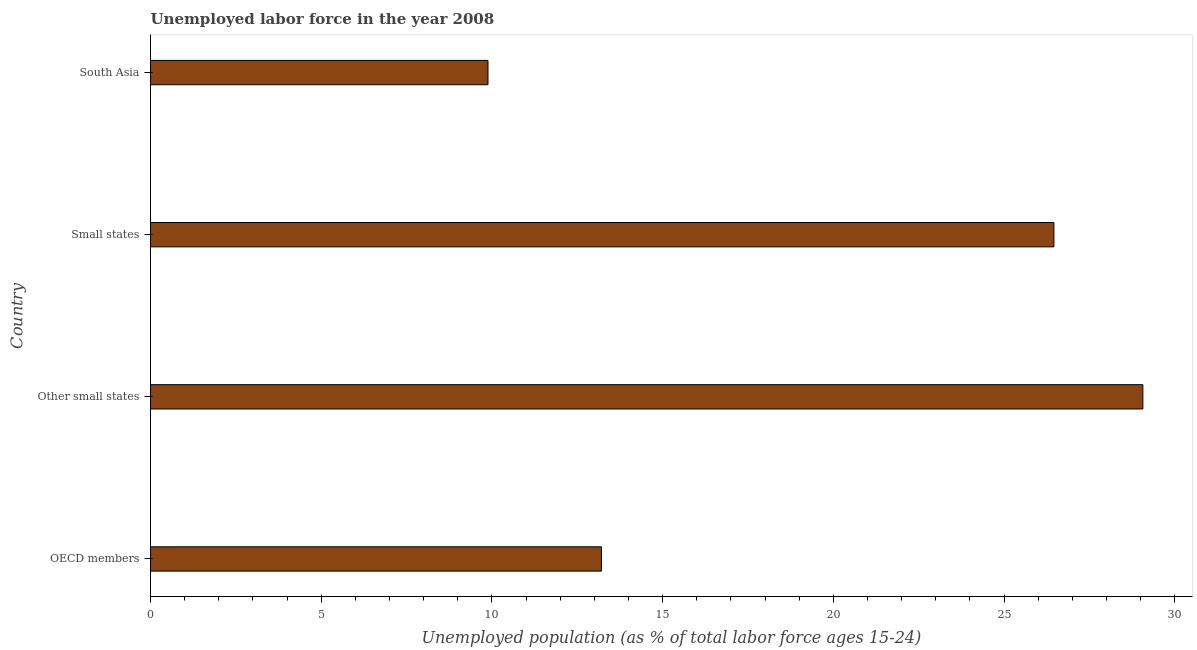What is the title of the graph?
Your answer should be very brief. Unemployed labor force in the year 2008. What is the label or title of the X-axis?
Your response must be concise. Unemployed population (as % of total labor force ages 15-24). What is the label or title of the Y-axis?
Provide a succinct answer. Country. What is the total unemployed youth population in South Asia?
Your answer should be very brief. 9.88. Across all countries, what is the maximum total unemployed youth population?
Make the answer very short. 29.07. Across all countries, what is the minimum total unemployed youth population?
Your answer should be compact. 9.88. In which country was the total unemployed youth population maximum?
Keep it short and to the point. Other small states. What is the sum of the total unemployed youth population?
Give a very brief answer. 78.62. What is the difference between the total unemployed youth population in Other small states and South Asia?
Your answer should be compact. 19.18. What is the average total unemployed youth population per country?
Ensure brevity in your answer.  19.65. What is the median total unemployed youth population?
Keep it short and to the point. 19.83. What is the ratio of the total unemployed youth population in OECD members to that in South Asia?
Offer a terse response. 1.34. What is the difference between the highest and the second highest total unemployed youth population?
Provide a succinct answer. 2.61. Is the sum of the total unemployed youth population in Other small states and Small states greater than the maximum total unemployed youth population across all countries?
Give a very brief answer. Yes. What is the difference between the highest and the lowest total unemployed youth population?
Your answer should be compact. 19.18. In how many countries, is the total unemployed youth population greater than the average total unemployed youth population taken over all countries?
Provide a short and direct response. 2. Are all the bars in the graph horizontal?
Offer a very short reply. Yes. Are the values on the major ticks of X-axis written in scientific E-notation?
Ensure brevity in your answer.  No. What is the Unemployed population (as % of total labor force ages 15-24) of OECD members?
Make the answer very short. 13.21. What is the Unemployed population (as % of total labor force ages 15-24) of Other small states?
Ensure brevity in your answer.  29.07. What is the Unemployed population (as % of total labor force ages 15-24) of Small states?
Provide a succinct answer. 26.46. What is the Unemployed population (as % of total labor force ages 15-24) of South Asia?
Ensure brevity in your answer.  9.88. What is the difference between the Unemployed population (as % of total labor force ages 15-24) in OECD members and Other small states?
Make the answer very short. -15.86. What is the difference between the Unemployed population (as % of total labor force ages 15-24) in OECD members and Small states?
Provide a short and direct response. -13.25. What is the difference between the Unemployed population (as % of total labor force ages 15-24) in OECD members and South Asia?
Keep it short and to the point. 3.32. What is the difference between the Unemployed population (as % of total labor force ages 15-24) in Other small states and Small states?
Provide a short and direct response. 2.61. What is the difference between the Unemployed population (as % of total labor force ages 15-24) in Other small states and South Asia?
Provide a short and direct response. 19.18. What is the difference between the Unemployed population (as % of total labor force ages 15-24) in Small states and South Asia?
Your answer should be compact. 16.58. What is the ratio of the Unemployed population (as % of total labor force ages 15-24) in OECD members to that in Other small states?
Make the answer very short. 0.45. What is the ratio of the Unemployed population (as % of total labor force ages 15-24) in OECD members to that in Small states?
Provide a short and direct response. 0.5. What is the ratio of the Unemployed population (as % of total labor force ages 15-24) in OECD members to that in South Asia?
Your answer should be compact. 1.34. What is the ratio of the Unemployed population (as % of total labor force ages 15-24) in Other small states to that in Small states?
Keep it short and to the point. 1.1. What is the ratio of the Unemployed population (as % of total labor force ages 15-24) in Other small states to that in South Asia?
Your answer should be compact. 2.94. What is the ratio of the Unemployed population (as % of total labor force ages 15-24) in Small states to that in South Asia?
Offer a terse response. 2.68. 